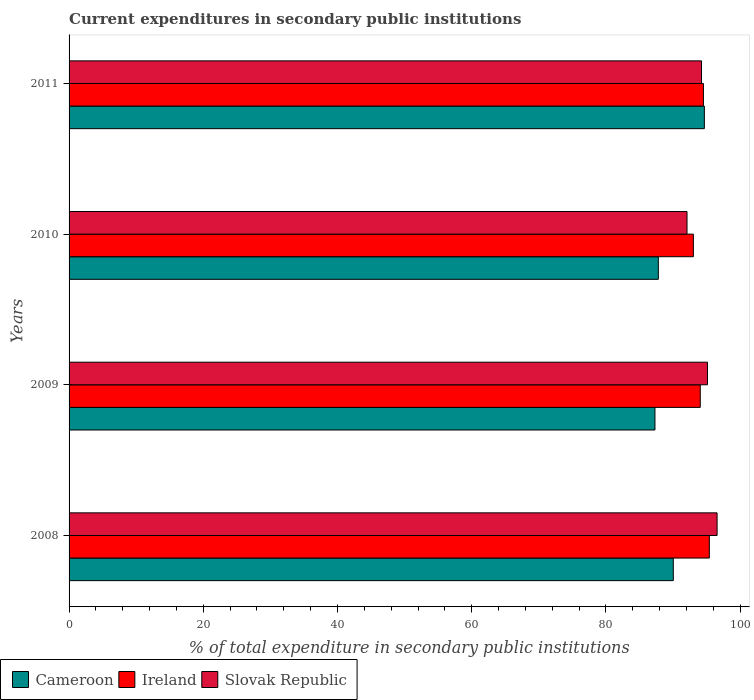How many different coloured bars are there?
Provide a succinct answer. 3. Are the number of bars on each tick of the Y-axis equal?
Offer a very short reply. Yes. How many bars are there on the 3rd tick from the top?
Your answer should be compact. 3. How many bars are there on the 1st tick from the bottom?
Provide a short and direct response. 3. What is the current expenditures in secondary public institutions in Cameroon in 2011?
Your answer should be very brief. 94.67. Across all years, what is the maximum current expenditures in secondary public institutions in Ireland?
Your answer should be compact. 95.41. Across all years, what is the minimum current expenditures in secondary public institutions in Cameroon?
Your response must be concise. 87.31. In which year was the current expenditures in secondary public institutions in Cameroon maximum?
Provide a succinct answer. 2011. In which year was the current expenditures in secondary public institutions in Ireland minimum?
Offer a terse response. 2010. What is the total current expenditures in secondary public institutions in Ireland in the graph?
Ensure brevity in your answer.  377.04. What is the difference between the current expenditures in secondary public institutions in Cameroon in 2008 and that in 2009?
Your answer should be very brief. 2.73. What is the difference between the current expenditures in secondary public institutions in Ireland in 2009 and the current expenditures in secondary public institutions in Cameroon in 2008?
Ensure brevity in your answer.  4.02. What is the average current expenditures in secondary public institutions in Cameroon per year?
Your answer should be very brief. 89.96. In the year 2008, what is the difference between the current expenditures in secondary public institutions in Cameroon and current expenditures in secondary public institutions in Slovak Republic?
Provide a succinct answer. -6.53. In how many years, is the current expenditures in secondary public institutions in Slovak Republic greater than 92 %?
Provide a succinct answer. 4. What is the ratio of the current expenditures in secondary public institutions in Ireland in 2009 to that in 2010?
Offer a very short reply. 1.01. Is the current expenditures in secondary public institutions in Slovak Republic in 2008 less than that in 2011?
Your answer should be compact. No. What is the difference between the highest and the second highest current expenditures in secondary public institutions in Cameroon?
Your response must be concise. 4.63. What is the difference between the highest and the lowest current expenditures in secondary public institutions in Ireland?
Offer a very short reply. 2.38. In how many years, is the current expenditures in secondary public institutions in Cameroon greater than the average current expenditures in secondary public institutions in Cameroon taken over all years?
Your answer should be very brief. 2. What does the 1st bar from the top in 2008 represents?
Your answer should be compact. Slovak Republic. What does the 3rd bar from the bottom in 2011 represents?
Keep it short and to the point. Slovak Republic. Is it the case that in every year, the sum of the current expenditures in secondary public institutions in Slovak Republic and current expenditures in secondary public institutions in Cameroon is greater than the current expenditures in secondary public institutions in Ireland?
Ensure brevity in your answer.  Yes. How many bars are there?
Ensure brevity in your answer.  12. Are all the bars in the graph horizontal?
Provide a succinct answer. Yes. Does the graph contain grids?
Provide a succinct answer. No. How many legend labels are there?
Ensure brevity in your answer.  3. What is the title of the graph?
Provide a succinct answer. Current expenditures in secondary public institutions. What is the label or title of the X-axis?
Provide a short and direct response. % of total expenditure in secondary public institutions. What is the label or title of the Y-axis?
Your answer should be very brief. Years. What is the % of total expenditure in secondary public institutions of Cameroon in 2008?
Provide a short and direct response. 90.04. What is the % of total expenditure in secondary public institutions in Ireland in 2008?
Your answer should be very brief. 95.41. What is the % of total expenditure in secondary public institutions of Slovak Republic in 2008?
Your answer should be compact. 96.57. What is the % of total expenditure in secondary public institutions in Cameroon in 2009?
Ensure brevity in your answer.  87.31. What is the % of total expenditure in secondary public institutions of Ireland in 2009?
Ensure brevity in your answer.  94.06. What is the % of total expenditure in secondary public institutions of Slovak Republic in 2009?
Keep it short and to the point. 95.13. What is the % of total expenditure in secondary public institutions in Cameroon in 2010?
Provide a succinct answer. 87.81. What is the % of total expenditure in secondary public institutions of Ireland in 2010?
Offer a very short reply. 93.03. What is the % of total expenditure in secondary public institutions of Slovak Republic in 2010?
Offer a terse response. 92.09. What is the % of total expenditure in secondary public institutions in Cameroon in 2011?
Offer a very short reply. 94.67. What is the % of total expenditure in secondary public institutions of Ireland in 2011?
Offer a terse response. 94.53. What is the % of total expenditure in secondary public institutions of Slovak Republic in 2011?
Provide a succinct answer. 94.25. Across all years, what is the maximum % of total expenditure in secondary public institutions of Cameroon?
Provide a short and direct response. 94.67. Across all years, what is the maximum % of total expenditure in secondary public institutions in Ireland?
Offer a terse response. 95.41. Across all years, what is the maximum % of total expenditure in secondary public institutions of Slovak Republic?
Your response must be concise. 96.57. Across all years, what is the minimum % of total expenditure in secondary public institutions of Cameroon?
Make the answer very short. 87.31. Across all years, what is the minimum % of total expenditure in secondary public institutions in Ireland?
Give a very brief answer. 93.03. Across all years, what is the minimum % of total expenditure in secondary public institutions of Slovak Republic?
Make the answer very short. 92.09. What is the total % of total expenditure in secondary public institutions in Cameroon in the graph?
Ensure brevity in your answer.  359.83. What is the total % of total expenditure in secondary public institutions of Ireland in the graph?
Keep it short and to the point. 377.04. What is the total % of total expenditure in secondary public institutions in Slovak Republic in the graph?
Provide a succinct answer. 378.04. What is the difference between the % of total expenditure in secondary public institutions in Cameroon in 2008 and that in 2009?
Your response must be concise. 2.73. What is the difference between the % of total expenditure in secondary public institutions in Ireland in 2008 and that in 2009?
Your response must be concise. 1.35. What is the difference between the % of total expenditure in secondary public institutions in Slovak Republic in 2008 and that in 2009?
Offer a terse response. 1.43. What is the difference between the % of total expenditure in secondary public institutions in Cameroon in 2008 and that in 2010?
Your answer should be compact. 2.23. What is the difference between the % of total expenditure in secondary public institutions of Ireland in 2008 and that in 2010?
Your answer should be compact. 2.38. What is the difference between the % of total expenditure in secondary public institutions of Slovak Republic in 2008 and that in 2010?
Give a very brief answer. 4.48. What is the difference between the % of total expenditure in secondary public institutions of Cameroon in 2008 and that in 2011?
Give a very brief answer. -4.63. What is the difference between the % of total expenditure in secondary public institutions of Ireland in 2008 and that in 2011?
Keep it short and to the point. 0.88. What is the difference between the % of total expenditure in secondary public institutions in Slovak Republic in 2008 and that in 2011?
Ensure brevity in your answer.  2.32. What is the difference between the % of total expenditure in secondary public institutions in Cameroon in 2009 and that in 2010?
Give a very brief answer. -0.5. What is the difference between the % of total expenditure in secondary public institutions in Ireland in 2009 and that in 2010?
Offer a terse response. 1.03. What is the difference between the % of total expenditure in secondary public institutions of Slovak Republic in 2009 and that in 2010?
Provide a succinct answer. 3.05. What is the difference between the % of total expenditure in secondary public institutions in Cameroon in 2009 and that in 2011?
Your response must be concise. -7.36. What is the difference between the % of total expenditure in secondary public institutions in Ireland in 2009 and that in 2011?
Provide a short and direct response. -0.47. What is the difference between the % of total expenditure in secondary public institutions of Slovak Republic in 2009 and that in 2011?
Give a very brief answer. 0.89. What is the difference between the % of total expenditure in secondary public institutions in Cameroon in 2010 and that in 2011?
Your answer should be very brief. -6.86. What is the difference between the % of total expenditure in secondary public institutions of Ireland in 2010 and that in 2011?
Your response must be concise. -1.5. What is the difference between the % of total expenditure in secondary public institutions of Slovak Republic in 2010 and that in 2011?
Your answer should be very brief. -2.16. What is the difference between the % of total expenditure in secondary public institutions in Cameroon in 2008 and the % of total expenditure in secondary public institutions in Ireland in 2009?
Make the answer very short. -4.02. What is the difference between the % of total expenditure in secondary public institutions in Cameroon in 2008 and the % of total expenditure in secondary public institutions in Slovak Republic in 2009?
Offer a terse response. -5.09. What is the difference between the % of total expenditure in secondary public institutions of Ireland in 2008 and the % of total expenditure in secondary public institutions of Slovak Republic in 2009?
Give a very brief answer. 0.28. What is the difference between the % of total expenditure in secondary public institutions of Cameroon in 2008 and the % of total expenditure in secondary public institutions of Ireland in 2010?
Provide a succinct answer. -2.99. What is the difference between the % of total expenditure in secondary public institutions in Cameroon in 2008 and the % of total expenditure in secondary public institutions in Slovak Republic in 2010?
Your answer should be compact. -2.05. What is the difference between the % of total expenditure in secondary public institutions in Ireland in 2008 and the % of total expenditure in secondary public institutions in Slovak Republic in 2010?
Ensure brevity in your answer.  3.32. What is the difference between the % of total expenditure in secondary public institutions in Cameroon in 2008 and the % of total expenditure in secondary public institutions in Ireland in 2011?
Ensure brevity in your answer.  -4.49. What is the difference between the % of total expenditure in secondary public institutions of Cameroon in 2008 and the % of total expenditure in secondary public institutions of Slovak Republic in 2011?
Ensure brevity in your answer.  -4.21. What is the difference between the % of total expenditure in secondary public institutions in Ireland in 2008 and the % of total expenditure in secondary public institutions in Slovak Republic in 2011?
Your response must be concise. 1.16. What is the difference between the % of total expenditure in secondary public institutions of Cameroon in 2009 and the % of total expenditure in secondary public institutions of Ireland in 2010?
Your response must be concise. -5.72. What is the difference between the % of total expenditure in secondary public institutions in Cameroon in 2009 and the % of total expenditure in secondary public institutions in Slovak Republic in 2010?
Your answer should be compact. -4.78. What is the difference between the % of total expenditure in secondary public institutions of Ireland in 2009 and the % of total expenditure in secondary public institutions of Slovak Republic in 2010?
Ensure brevity in your answer.  1.97. What is the difference between the % of total expenditure in secondary public institutions in Cameroon in 2009 and the % of total expenditure in secondary public institutions in Ireland in 2011?
Provide a succinct answer. -7.22. What is the difference between the % of total expenditure in secondary public institutions of Cameroon in 2009 and the % of total expenditure in secondary public institutions of Slovak Republic in 2011?
Ensure brevity in your answer.  -6.94. What is the difference between the % of total expenditure in secondary public institutions of Ireland in 2009 and the % of total expenditure in secondary public institutions of Slovak Republic in 2011?
Offer a terse response. -0.19. What is the difference between the % of total expenditure in secondary public institutions of Cameroon in 2010 and the % of total expenditure in secondary public institutions of Ireland in 2011?
Offer a terse response. -6.72. What is the difference between the % of total expenditure in secondary public institutions of Cameroon in 2010 and the % of total expenditure in secondary public institutions of Slovak Republic in 2011?
Keep it short and to the point. -6.44. What is the difference between the % of total expenditure in secondary public institutions in Ireland in 2010 and the % of total expenditure in secondary public institutions in Slovak Republic in 2011?
Keep it short and to the point. -1.22. What is the average % of total expenditure in secondary public institutions in Cameroon per year?
Provide a short and direct response. 89.96. What is the average % of total expenditure in secondary public institutions in Ireland per year?
Ensure brevity in your answer.  94.26. What is the average % of total expenditure in secondary public institutions in Slovak Republic per year?
Your answer should be very brief. 94.51. In the year 2008, what is the difference between the % of total expenditure in secondary public institutions of Cameroon and % of total expenditure in secondary public institutions of Ireland?
Your response must be concise. -5.37. In the year 2008, what is the difference between the % of total expenditure in secondary public institutions of Cameroon and % of total expenditure in secondary public institutions of Slovak Republic?
Offer a terse response. -6.53. In the year 2008, what is the difference between the % of total expenditure in secondary public institutions of Ireland and % of total expenditure in secondary public institutions of Slovak Republic?
Ensure brevity in your answer.  -1.16. In the year 2009, what is the difference between the % of total expenditure in secondary public institutions in Cameroon and % of total expenditure in secondary public institutions in Ireland?
Provide a short and direct response. -6.75. In the year 2009, what is the difference between the % of total expenditure in secondary public institutions in Cameroon and % of total expenditure in secondary public institutions in Slovak Republic?
Make the answer very short. -7.83. In the year 2009, what is the difference between the % of total expenditure in secondary public institutions in Ireland and % of total expenditure in secondary public institutions in Slovak Republic?
Provide a short and direct response. -1.07. In the year 2010, what is the difference between the % of total expenditure in secondary public institutions in Cameroon and % of total expenditure in secondary public institutions in Ireland?
Offer a terse response. -5.22. In the year 2010, what is the difference between the % of total expenditure in secondary public institutions in Cameroon and % of total expenditure in secondary public institutions in Slovak Republic?
Provide a succinct answer. -4.28. In the year 2010, what is the difference between the % of total expenditure in secondary public institutions in Ireland and % of total expenditure in secondary public institutions in Slovak Republic?
Ensure brevity in your answer.  0.95. In the year 2011, what is the difference between the % of total expenditure in secondary public institutions in Cameroon and % of total expenditure in secondary public institutions in Ireland?
Your response must be concise. 0.14. In the year 2011, what is the difference between the % of total expenditure in secondary public institutions of Cameroon and % of total expenditure in secondary public institutions of Slovak Republic?
Your answer should be very brief. 0.42. In the year 2011, what is the difference between the % of total expenditure in secondary public institutions of Ireland and % of total expenditure in secondary public institutions of Slovak Republic?
Your response must be concise. 0.28. What is the ratio of the % of total expenditure in secondary public institutions in Cameroon in 2008 to that in 2009?
Provide a succinct answer. 1.03. What is the ratio of the % of total expenditure in secondary public institutions in Ireland in 2008 to that in 2009?
Provide a short and direct response. 1.01. What is the ratio of the % of total expenditure in secondary public institutions in Slovak Republic in 2008 to that in 2009?
Your response must be concise. 1.02. What is the ratio of the % of total expenditure in secondary public institutions of Cameroon in 2008 to that in 2010?
Make the answer very short. 1.03. What is the ratio of the % of total expenditure in secondary public institutions in Ireland in 2008 to that in 2010?
Keep it short and to the point. 1.03. What is the ratio of the % of total expenditure in secondary public institutions of Slovak Republic in 2008 to that in 2010?
Provide a succinct answer. 1.05. What is the ratio of the % of total expenditure in secondary public institutions of Cameroon in 2008 to that in 2011?
Your answer should be very brief. 0.95. What is the ratio of the % of total expenditure in secondary public institutions in Ireland in 2008 to that in 2011?
Your response must be concise. 1.01. What is the ratio of the % of total expenditure in secondary public institutions in Slovak Republic in 2008 to that in 2011?
Offer a very short reply. 1.02. What is the ratio of the % of total expenditure in secondary public institutions in Ireland in 2009 to that in 2010?
Your response must be concise. 1.01. What is the ratio of the % of total expenditure in secondary public institutions in Slovak Republic in 2009 to that in 2010?
Your answer should be compact. 1.03. What is the ratio of the % of total expenditure in secondary public institutions of Cameroon in 2009 to that in 2011?
Offer a terse response. 0.92. What is the ratio of the % of total expenditure in secondary public institutions of Slovak Republic in 2009 to that in 2011?
Make the answer very short. 1.01. What is the ratio of the % of total expenditure in secondary public institutions in Cameroon in 2010 to that in 2011?
Provide a succinct answer. 0.93. What is the ratio of the % of total expenditure in secondary public institutions in Ireland in 2010 to that in 2011?
Make the answer very short. 0.98. What is the ratio of the % of total expenditure in secondary public institutions in Slovak Republic in 2010 to that in 2011?
Your response must be concise. 0.98. What is the difference between the highest and the second highest % of total expenditure in secondary public institutions of Cameroon?
Ensure brevity in your answer.  4.63. What is the difference between the highest and the second highest % of total expenditure in secondary public institutions in Ireland?
Your answer should be compact. 0.88. What is the difference between the highest and the second highest % of total expenditure in secondary public institutions of Slovak Republic?
Provide a succinct answer. 1.43. What is the difference between the highest and the lowest % of total expenditure in secondary public institutions in Cameroon?
Keep it short and to the point. 7.36. What is the difference between the highest and the lowest % of total expenditure in secondary public institutions of Ireland?
Your answer should be compact. 2.38. What is the difference between the highest and the lowest % of total expenditure in secondary public institutions of Slovak Republic?
Your response must be concise. 4.48. 